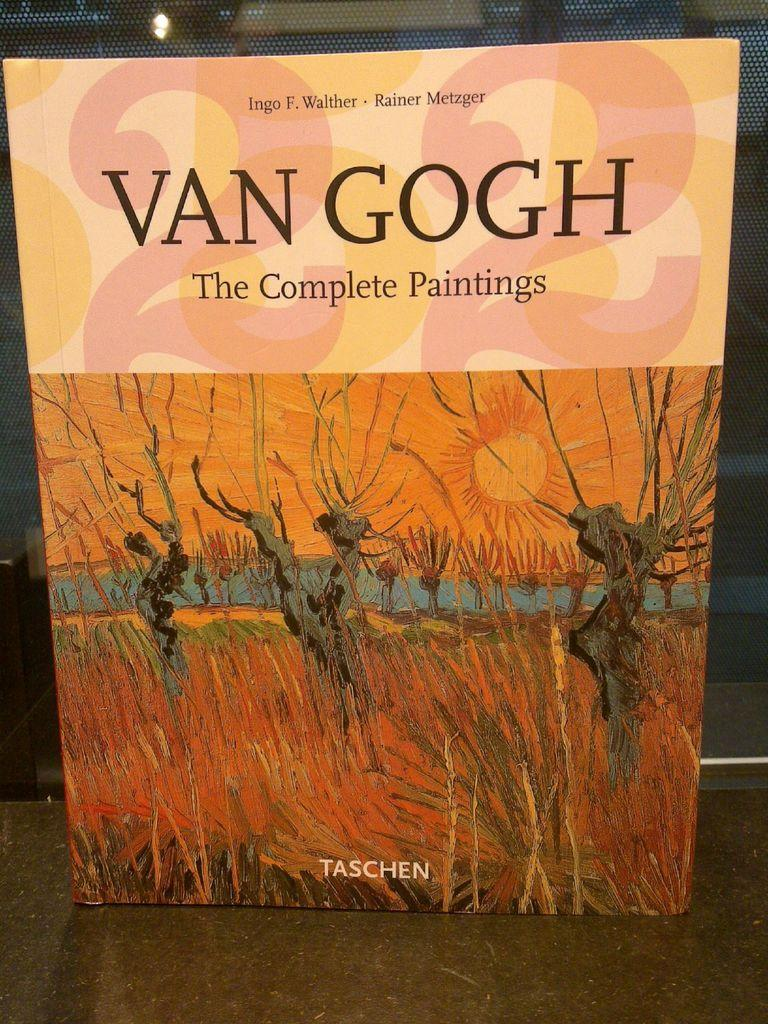<image>
Provide a brief description of the given image. A book titled Van Gough, the complete paintings, stands on end. 